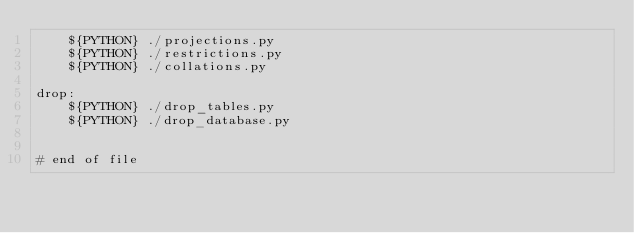Convert code to text. <code><loc_0><loc_0><loc_500><loc_500><_ObjectiveC_>	${PYTHON} ./projections.py
	${PYTHON} ./restrictions.py
	${PYTHON} ./collations.py

drop:
	${PYTHON} ./drop_tables.py
	${PYTHON} ./drop_database.py


# end of file
</code> 